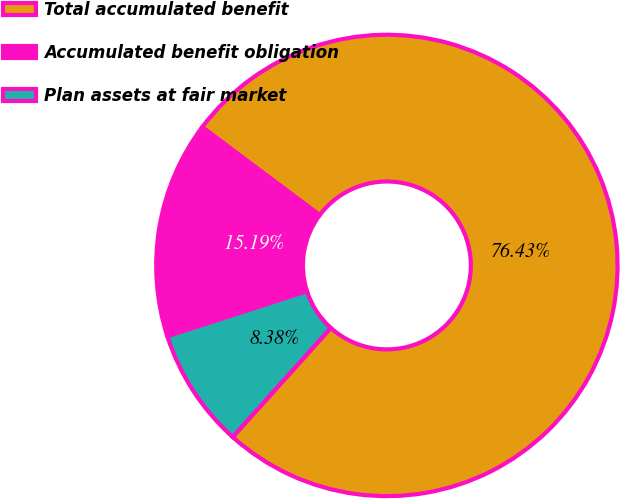Convert chart. <chart><loc_0><loc_0><loc_500><loc_500><pie_chart><fcel>Total accumulated benefit<fcel>Accumulated benefit obligation<fcel>Plan assets at fair market<nl><fcel>76.43%<fcel>15.19%<fcel>8.38%<nl></chart> 